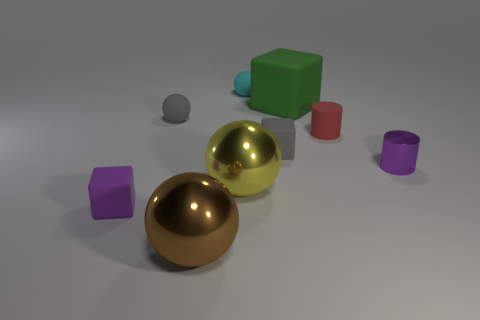Does the purple object to the left of the brown metallic ball have the same material as the small cylinder that is behind the small shiny cylinder?
Offer a very short reply. Yes. Is there a big matte cylinder that has the same color as the big block?
Offer a terse response. No. The other cylinder that is the same size as the red cylinder is what color?
Provide a short and direct response. Purple. There is a shiny sphere that is behind the tiny purple rubber cube; does it have the same color as the big rubber thing?
Offer a terse response. No. Are there any cyan spheres that have the same material as the purple cube?
Give a very brief answer. Yes. Are there fewer tiny purple things in front of the big brown metallic thing than tiny purple cylinders?
Your answer should be compact. Yes. There is a gray rubber thing left of the yellow ball; does it have the same size as the small purple shiny object?
Your answer should be very brief. Yes. What number of large brown objects are the same shape as the purple matte object?
Give a very brief answer. 0. There is a yellow object that is the same material as the large brown object; what size is it?
Your answer should be compact. Large. Are there the same number of tiny rubber balls that are in front of the large rubber cube and tiny gray cubes?
Offer a very short reply. Yes. 